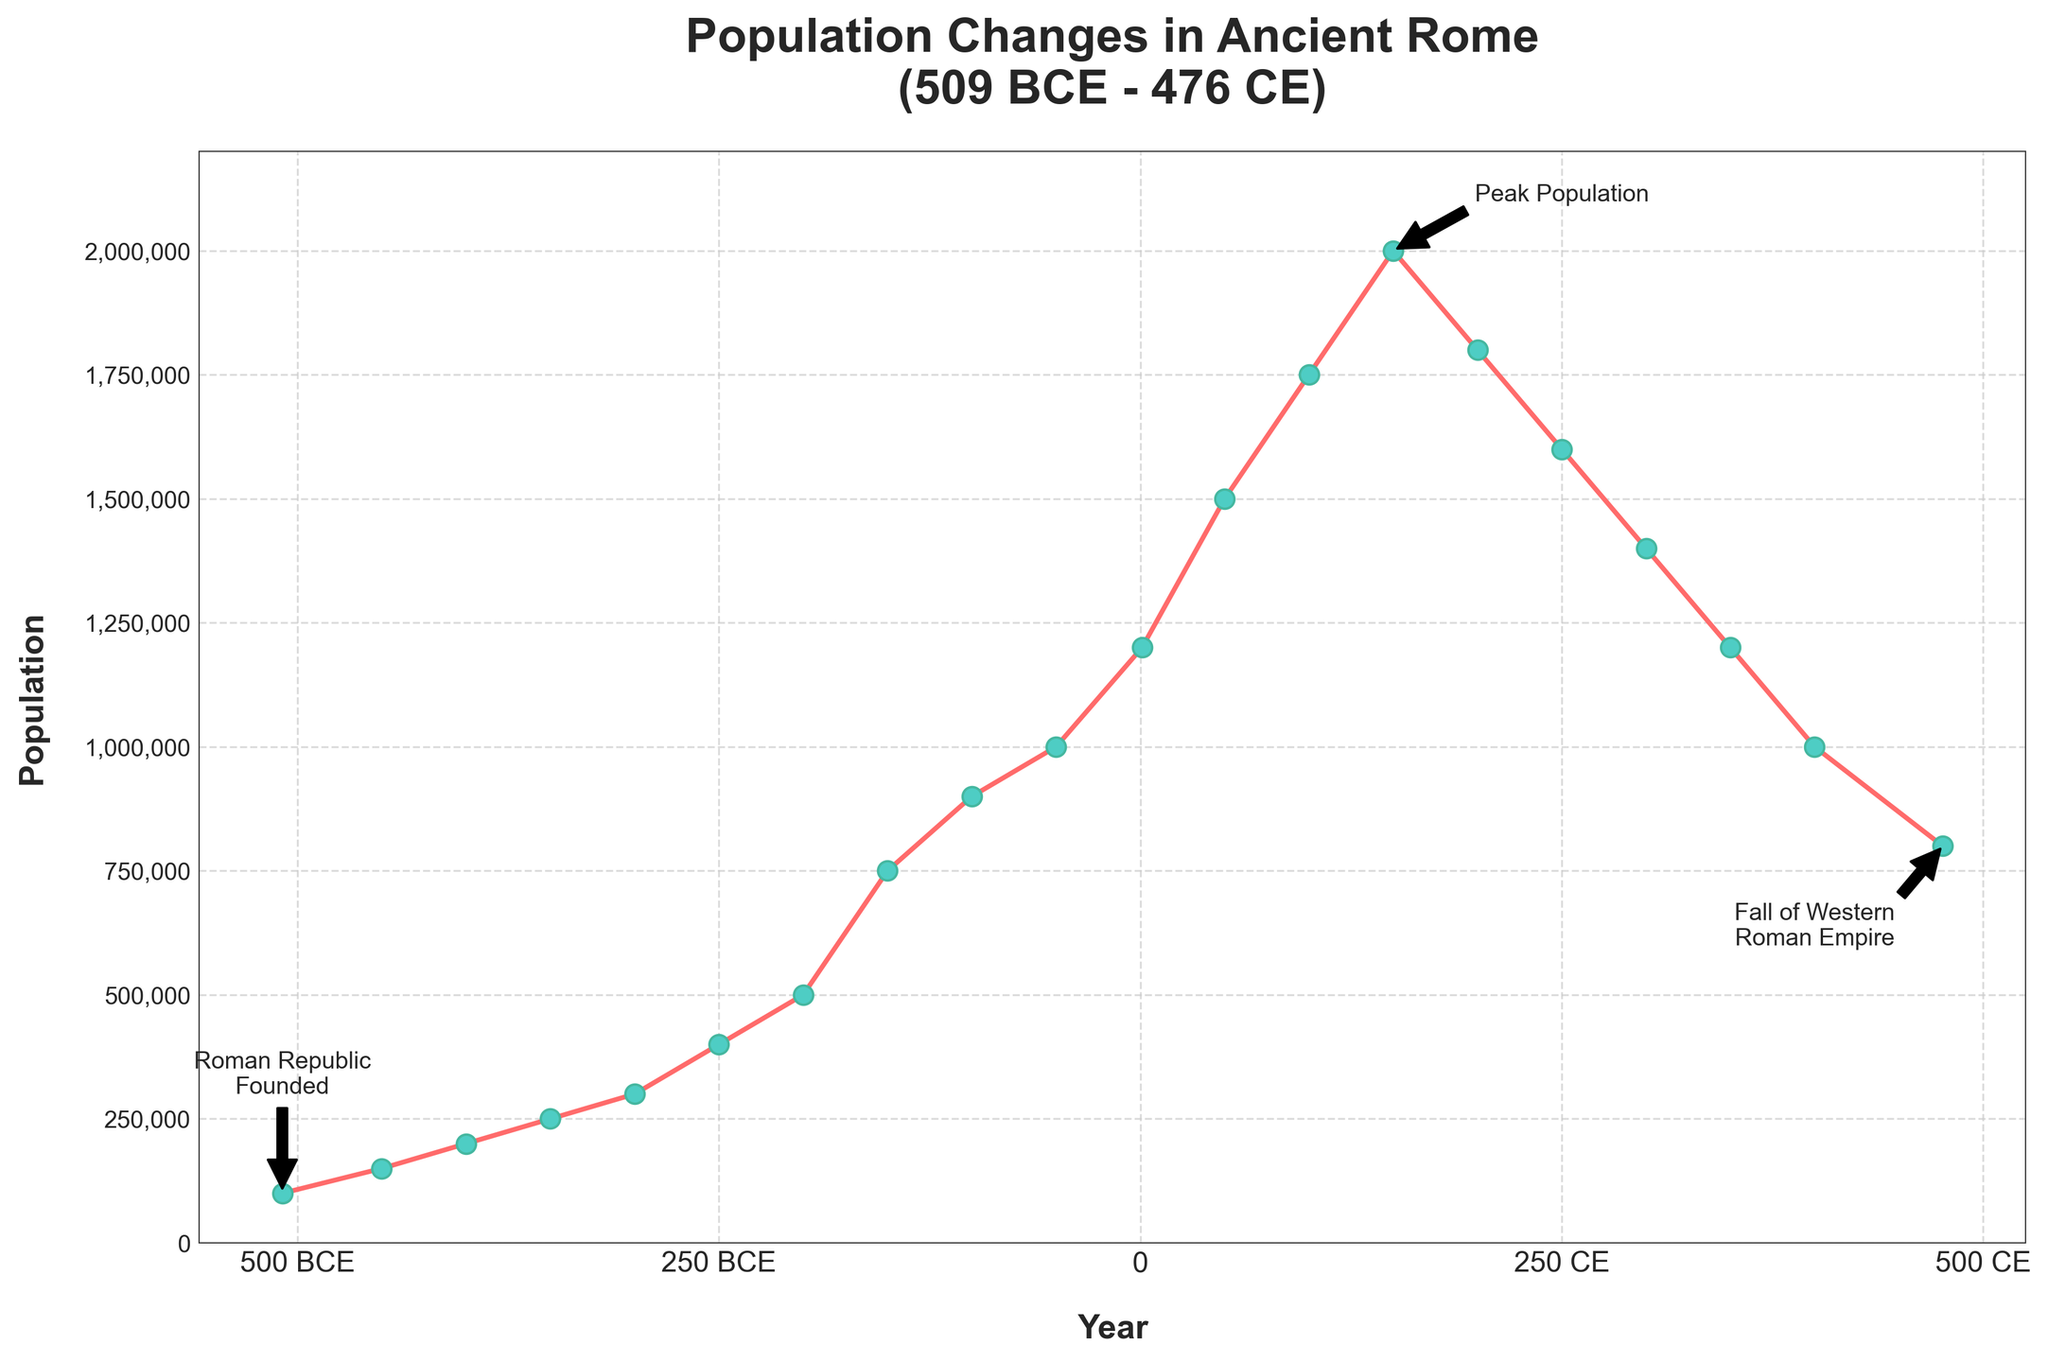What is the population in 100 BCE? To find the population in 100 BCE, locate the point at 100 BCE on the x-axis and read the corresponding value on the y-axis.
Answer: 900,000 During which year did Ancient Rome reach its peak population? The peak population is shown by the highest point on the graph. The highest population value occurs at 200 CE.
Answer: 200 CE How did the population change from 509 BCE to 200 BCE? Locate the population values for 509 BCE (100,000) and 200 BCE (500,000) and compute the difference: 500,000 - 100,000 = 400,000.
Answer: Increased by 400,000 Compare the population between 150 CE and 476 CE. For 150 CE, the population is 2,000,000. For 476 CE, the population is 800,000. 2,000,000 - 800,000 = 1,200,000.
Answer: 150 CE was 1,200,000 higher than 476 CE What is the average population from 1 CE to 150 CE? Identify populations for 1 CE (1,200,000), 50 CE (1,500,000), 100 CE (1,750,000), and 150 CE (2,000,000). Compute the average: (1,200,000 + 1,500,000 + 1,750,000 + 2,000,000) / 4 = 6,450,000 / 4 = 1,612,500.
Answer: 1,612,500 Which period saw the fastest growth in population? The steepest slope in the line indicates the fastest growth. Between 200 BCE (500,000) and 100 BCE (900,000) is the sharpest increase.
Answer: 200 BCE to 100 BCE Is the population higher in 250 BCE or 476 CE? Locate the points for 250 BCE (400,000) and 476 CE (800,000). The population in 476 CE is higher.
Answer: 476 CE What is the decline in population from the peak to 476 CE? Peak population is 2,000,000 at 200 CE. By 476 CE it declined to 800,000. Difference: 2,000,000 - 800,000 = 1,200,000.
Answer: Declined by 1,200,000 